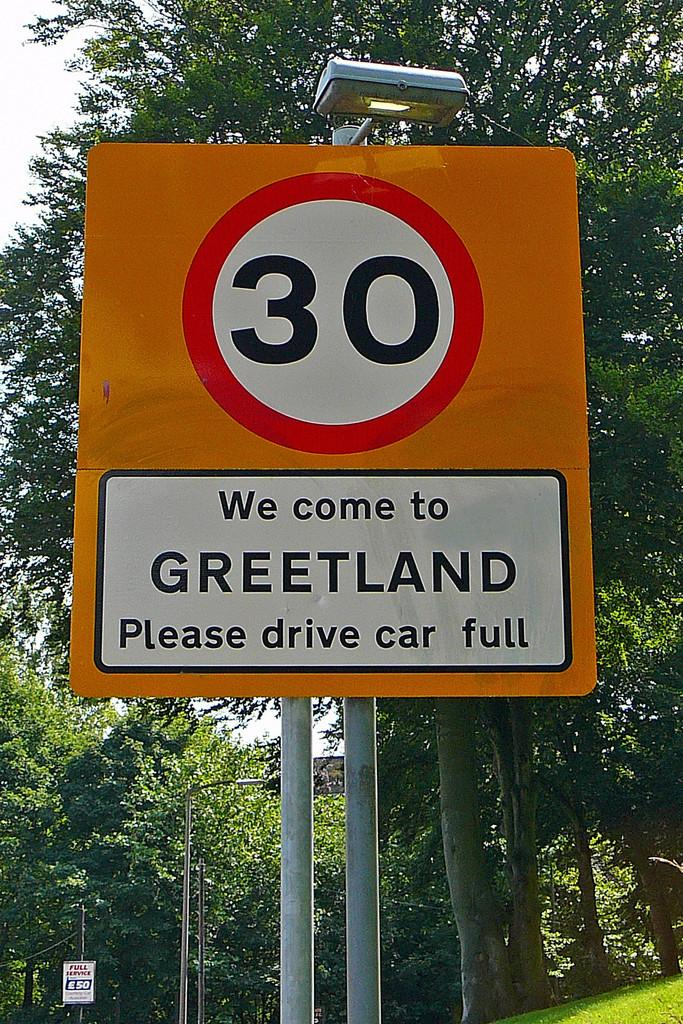Provide a one-sentence caption for the provided image. A sign with the number 30 and Greetland on it. 